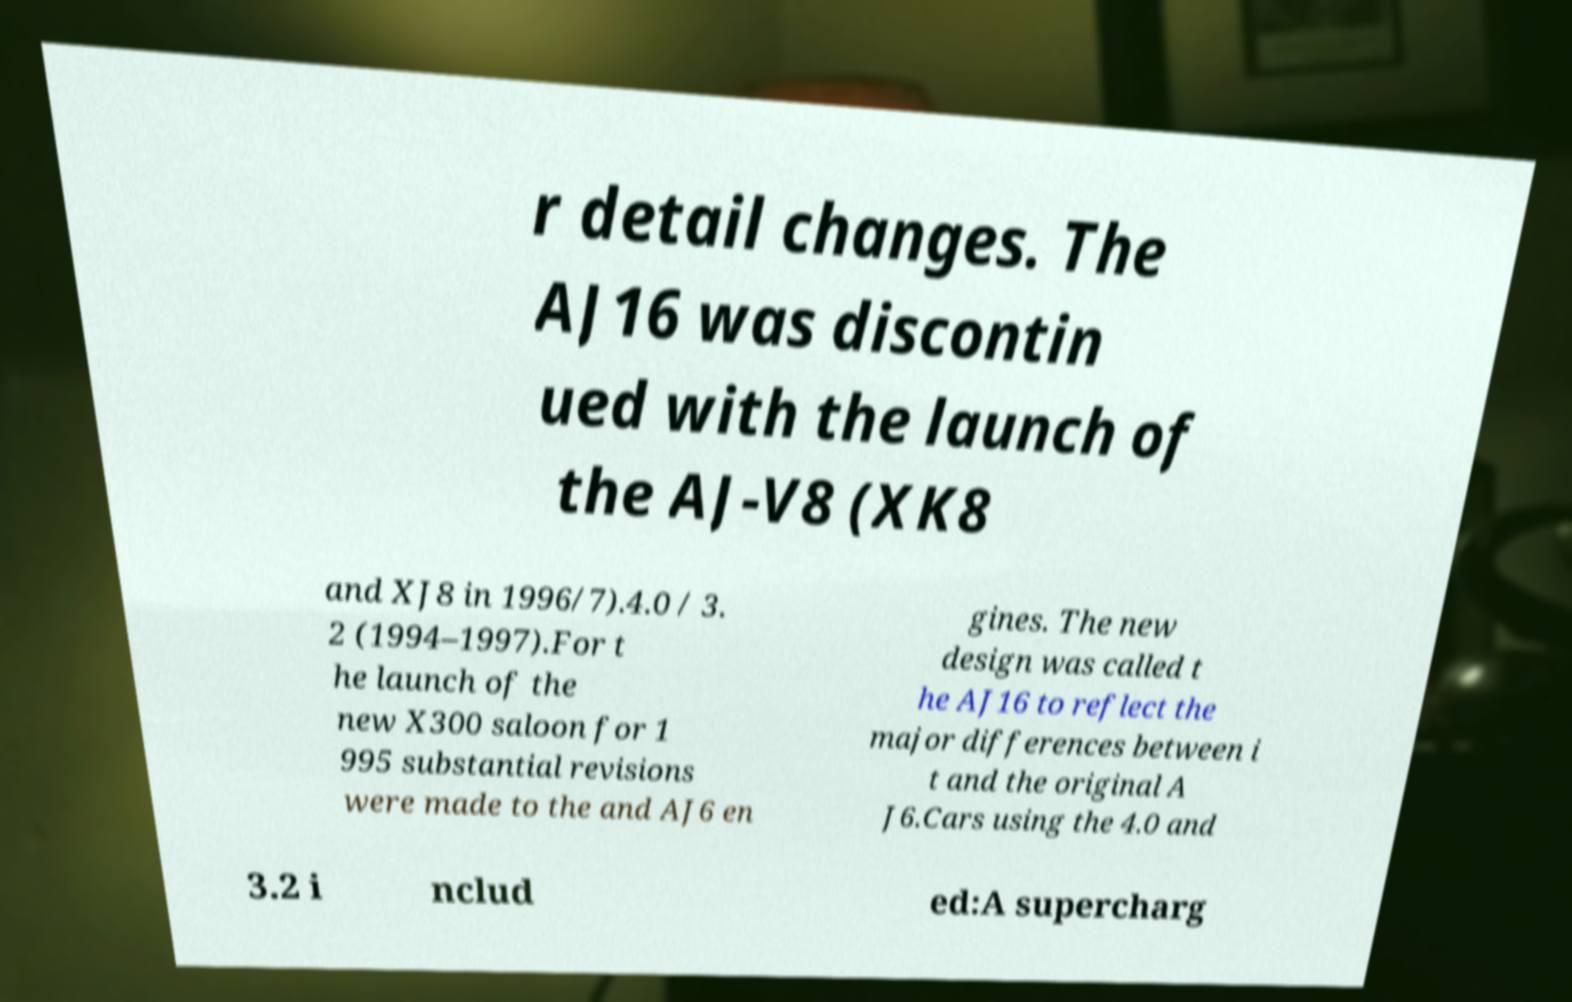There's text embedded in this image that I need extracted. Can you transcribe it verbatim? r detail changes. The AJ16 was discontin ued with the launch of the AJ-V8 (XK8 and XJ8 in 1996/7).4.0 / 3. 2 (1994–1997).For t he launch of the new X300 saloon for 1 995 substantial revisions were made to the and AJ6 en gines. The new design was called t he AJ16 to reflect the major differences between i t and the original A J6.Cars using the 4.0 and 3.2 i nclud ed:A supercharg 